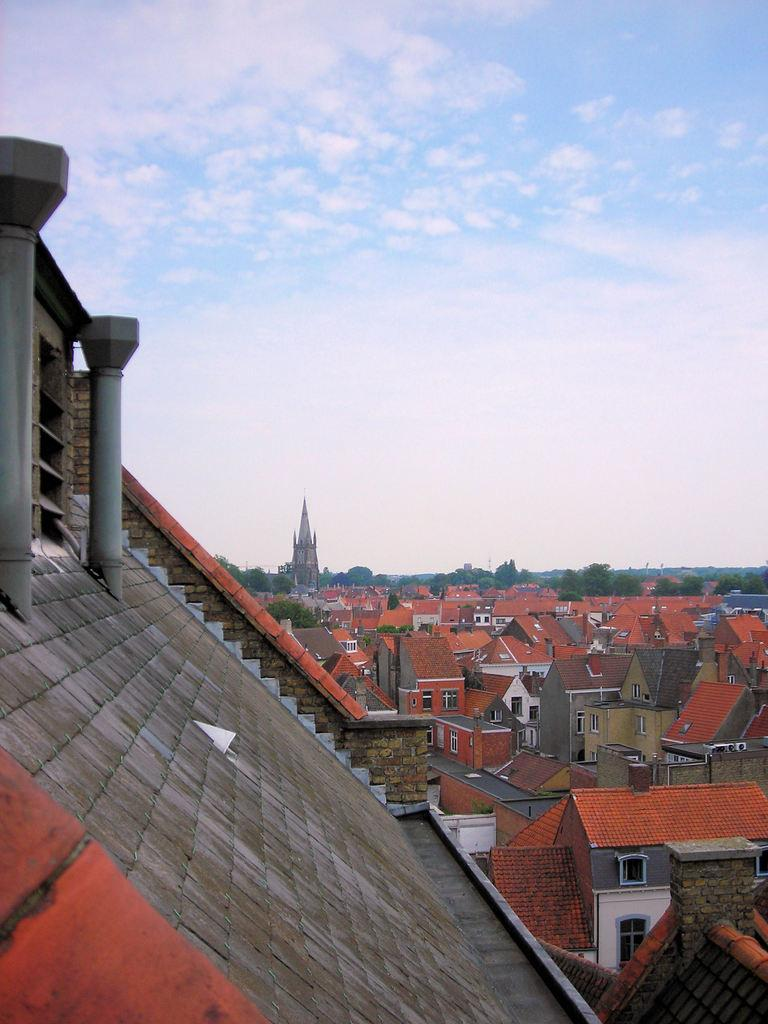What type of structures are visible in the image? There are houses in the image. What can be seen in the background of the image? There is a tower and trees in the background of the image. How would you describe the sky in the image? The sky is cloudy in the image. How many deer can be seen grazing in the field in the image? There are no deer or fields present in the image. 